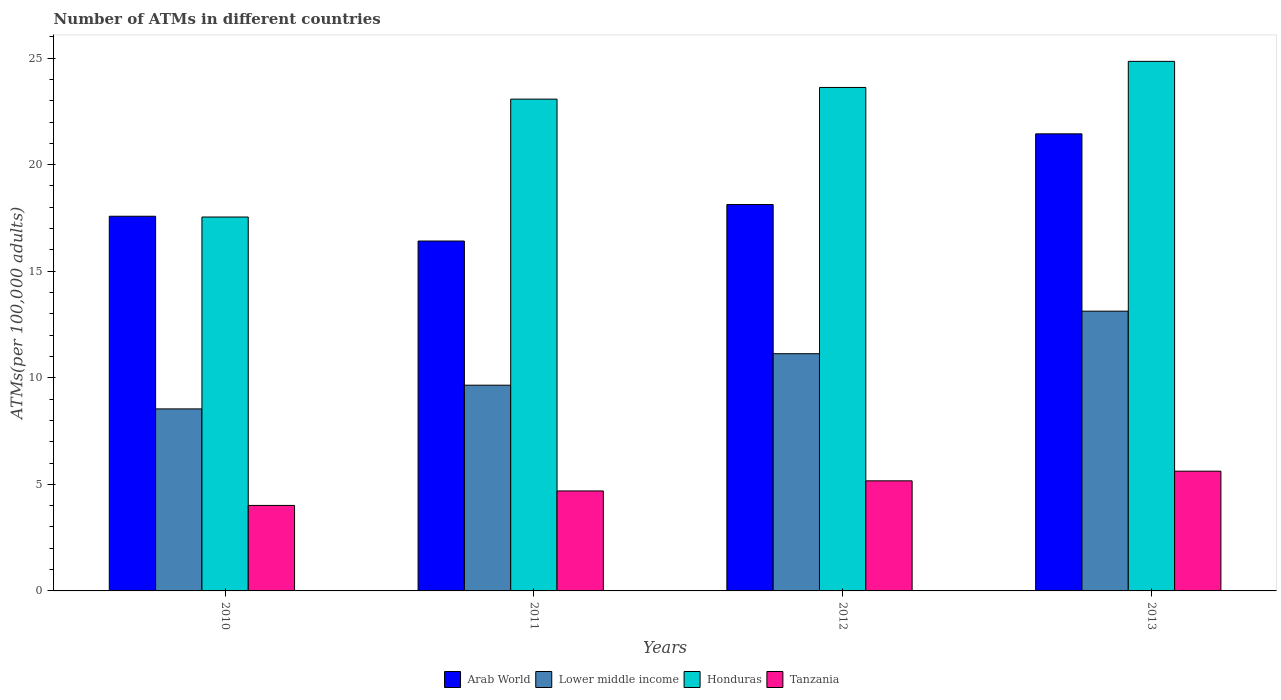How many different coloured bars are there?
Ensure brevity in your answer.  4. How many groups of bars are there?
Your answer should be very brief. 4. Are the number of bars per tick equal to the number of legend labels?
Your answer should be compact. Yes. How many bars are there on the 2nd tick from the left?
Give a very brief answer. 4. What is the label of the 2nd group of bars from the left?
Your answer should be compact. 2011. In how many cases, is the number of bars for a given year not equal to the number of legend labels?
Offer a terse response. 0. What is the number of ATMs in Tanzania in 2012?
Provide a short and direct response. 5.16. Across all years, what is the maximum number of ATMs in Tanzania?
Make the answer very short. 5.62. Across all years, what is the minimum number of ATMs in Arab World?
Your answer should be very brief. 16.42. In which year was the number of ATMs in Lower middle income minimum?
Your answer should be very brief. 2010. What is the total number of ATMs in Honduras in the graph?
Your answer should be compact. 89.08. What is the difference between the number of ATMs in Tanzania in 2010 and that in 2012?
Ensure brevity in your answer.  -1.15. What is the difference between the number of ATMs in Honduras in 2011 and the number of ATMs in Tanzania in 2013?
Ensure brevity in your answer.  17.45. What is the average number of ATMs in Lower middle income per year?
Offer a very short reply. 10.61. In the year 2013, what is the difference between the number of ATMs in Arab World and number of ATMs in Lower middle income?
Your answer should be very brief. 8.32. What is the ratio of the number of ATMs in Lower middle income in 2012 to that in 2013?
Your response must be concise. 0.85. Is the difference between the number of ATMs in Arab World in 2012 and 2013 greater than the difference between the number of ATMs in Lower middle income in 2012 and 2013?
Provide a short and direct response. No. What is the difference between the highest and the second highest number of ATMs in Arab World?
Provide a succinct answer. 3.32. What is the difference between the highest and the lowest number of ATMs in Tanzania?
Provide a short and direct response. 1.61. Is the sum of the number of ATMs in Tanzania in 2010 and 2011 greater than the maximum number of ATMs in Arab World across all years?
Offer a very short reply. No. What does the 2nd bar from the left in 2012 represents?
Ensure brevity in your answer.  Lower middle income. What does the 3rd bar from the right in 2010 represents?
Your answer should be compact. Lower middle income. Is it the case that in every year, the sum of the number of ATMs in Lower middle income and number of ATMs in Honduras is greater than the number of ATMs in Arab World?
Offer a very short reply. Yes. How many bars are there?
Provide a short and direct response. 16. Are all the bars in the graph horizontal?
Your response must be concise. No. How many years are there in the graph?
Your response must be concise. 4. Does the graph contain any zero values?
Give a very brief answer. No. How many legend labels are there?
Keep it short and to the point. 4. What is the title of the graph?
Your answer should be compact. Number of ATMs in different countries. What is the label or title of the Y-axis?
Provide a short and direct response. ATMs(per 100,0 adults). What is the ATMs(per 100,000 adults) in Arab World in 2010?
Offer a very short reply. 17.58. What is the ATMs(per 100,000 adults) of Lower middle income in 2010?
Ensure brevity in your answer.  8.54. What is the ATMs(per 100,000 adults) in Honduras in 2010?
Provide a short and direct response. 17.54. What is the ATMs(per 100,000 adults) of Tanzania in 2010?
Provide a succinct answer. 4.01. What is the ATMs(per 100,000 adults) in Arab World in 2011?
Offer a very short reply. 16.42. What is the ATMs(per 100,000 adults) in Lower middle income in 2011?
Your response must be concise. 9.65. What is the ATMs(per 100,000 adults) in Honduras in 2011?
Your answer should be compact. 23.07. What is the ATMs(per 100,000 adults) of Tanzania in 2011?
Provide a short and direct response. 4.69. What is the ATMs(per 100,000 adults) in Arab World in 2012?
Give a very brief answer. 18.13. What is the ATMs(per 100,000 adults) in Lower middle income in 2012?
Your answer should be compact. 11.13. What is the ATMs(per 100,000 adults) in Honduras in 2012?
Your response must be concise. 23.62. What is the ATMs(per 100,000 adults) of Tanzania in 2012?
Offer a very short reply. 5.16. What is the ATMs(per 100,000 adults) in Arab World in 2013?
Offer a terse response. 21.44. What is the ATMs(per 100,000 adults) in Lower middle income in 2013?
Keep it short and to the point. 13.13. What is the ATMs(per 100,000 adults) of Honduras in 2013?
Your answer should be very brief. 24.85. What is the ATMs(per 100,000 adults) of Tanzania in 2013?
Your response must be concise. 5.62. Across all years, what is the maximum ATMs(per 100,000 adults) in Arab World?
Your answer should be very brief. 21.44. Across all years, what is the maximum ATMs(per 100,000 adults) of Lower middle income?
Make the answer very short. 13.13. Across all years, what is the maximum ATMs(per 100,000 adults) in Honduras?
Ensure brevity in your answer.  24.85. Across all years, what is the maximum ATMs(per 100,000 adults) of Tanzania?
Offer a terse response. 5.62. Across all years, what is the minimum ATMs(per 100,000 adults) in Arab World?
Offer a very short reply. 16.42. Across all years, what is the minimum ATMs(per 100,000 adults) of Lower middle income?
Provide a short and direct response. 8.54. Across all years, what is the minimum ATMs(per 100,000 adults) of Honduras?
Your response must be concise. 17.54. Across all years, what is the minimum ATMs(per 100,000 adults) of Tanzania?
Your answer should be compact. 4.01. What is the total ATMs(per 100,000 adults) in Arab World in the graph?
Your response must be concise. 73.57. What is the total ATMs(per 100,000 adults) of Lower middle income in the graph?
Make the answer very short. 42.45. What is the total ATMs(per 100,000 adults) of Honduras in the graph?
Your response must be concise. 89.08. What is the total ATMs(per 100,000 adults) of Tanzania in the graph?
Give a very brief answer. 19.48. What is the difference between the ATMs(per 100,000 adults) in Arab World in 2010 and that in 2011?
Your answer should be compact. 1.16. What is the difference between the ATMs(per 100,000 adults) in Lower middle income in 2010 and that in 2011?
Make the answer very short. -1.11. What is the difference between the ATMs(per 100,000 adults) of Honduras in 2010 and that in 2011?
Your answer should be very brief. -5.53. What is the difference between the ATMs(per 100,000 adults) of Tanzania in 2010 and that in 2011?
Your answer should be compact. -0.68. What is the difference between the ATMs(per 100,000 adults) in Arab World in 2010 and that in 2012?
Your answer should be compact. -0.55. What is the difference between the ATMs(per 100,000 adults) of Lower middle income in 2010 and that in 2012?
Your answer should be very brief. -2.59. What is the difference between the ATMs(per 100,000 adults) in Honduras in 2010 and that in 2012?
Give a very brief answer. -6.08. What is the difference between the ATMs(per 100,000 adults) in Tanzania in 2010 and that in 2012?
Your answer should be compact. -1.15. What is the difference between the ATMs(per 100,000 adults) in Arab World in 2010 and that in 2013?
Give a very brief answer. -3.87. What is the difference between the ATMs(per 100,000 adults) of Lower middle income in 2010 and that in 2013?
Offer a terse response. -4.59. What is the difference between the ATMs(per 100,000 adults) in Honduras in 2010 and that in 2013?
Give a very brief answer. -7.3. What is the difference between the ATMs(per 100,000 adults) of Tanzania in 2010 and that in 2013?
Provide a short and direct response. -1.61. What is the difference between the ATMs(per 100,000 adults) in Arab World in 2011 and that in 2012?
Offer a very short reply. -1.71. What is the difference between the ATMs(per 100,000 adults) in Lower middle income in 2011 and that in 2012?
Your response must be concise. -1.48. What is the difference between the ATMs(per 100,000 adults) of Honduras in 2011 and that in 2012?
Offer a terse response. -0.55. What is the difference between the ATMs(per 100,000 adults) in Tanzania in 2011 and that in 2012?
Make the answer very short. -0.47. What is the difference between the ATMs(per 100,000 adults) of Arab World in 2011 and that in 2013?
Your answer should be very brief. -5.03. What is the difference between the ATMs(per 100,000 adults) of Lower middle income in 2011 and that in 2013?
Provide a short and direct response. -3.47. What is the difference between the ATMs(per 100,000 adults) of Honduras in 2011 and that in 2013?
Provide a short and direct response. -1.77. What is the difference between the ATMs(per 100,000 adults) of Tanzania in 2011 and that in 2013?
Your answer should be very brief. -0.93. What is the difference between the ATMs(per 100,000 adults) in Arab World in 2012 and that in 2013?
Ensure brevity in your answer.  -3.32. What is the difference between the ATMs(per 100,000 adults) in Lower middle income in 2012 and that in 2013?
Provide a short and direct response. -2. What is the difference between the ATMs(per 100,000 adults) in Honduras in 2012 and that in 2013?
Give a very brief answer. -1.22. What is the difference between the ATMs(per 100,000 adults) of Tanzania in 2012 and that in 2013?
Your response must be concise. -0.45. What is the difference between the ATMs(per 100,000 adults) of Arab World in 2010 and the ATMs(per 100,000 adults) of Lower middle income in 2011?
Make the answer very short. 7.93. What is the difference between the ATMs(per 100,000 adults) in Arab World in 2010 and the ATMs(per 100,000 adults) in Honduras in 2011?
Provide a succinct answer. -5.49. What is the difference between the ATMs(per 100,000 adults) of Arab World in 2010 and the ATMs(per 100,000 adults) of Tanzania in 2011?
Ensure brevity in your answer.  12.89. What is the difference between the ATMs(per 100,000 adults) in Lower middle income in 2010 and the ATMs(per 100,000 adults) in Honduras in 2011?
Ensure brevity in your answer.  -14.53. What is the difference between the ATMs(per 100,000 adults) of Lower middle income in 2010 and the ATMs(per 100,000 adults) of Tanzania in 2011?
Provide a succinct answer. 3.85. What is the difference between the ATMs(per 100,000 adults) in Honduras in 2010 and the ATMs(per 100,000 adults) in Tanzania in 2011?
Provide a succinct answer. 12.85. What is the difference between the ATMs(per 100,000 adults) in Arab World in 2010 and the ATMs(per 100,000 adults) in Lower middle income in 2012?
Your response must be concise. 6.45. What is the difference between the ATMs(per 100,000 adults) of Arab World in 2010 and the ATMs(per 100,000 adults) of Honduras in 2012?
Provide a succinct answer. -6.04. What is the difference between the ATMs(per 100,000 adults) in Arab World in 2010 and the ATMs(per 100,000 adults) in Tanzania in 2012?
Offer a terse response. 12.41. What is the difference between the ATMs(per 100,000 adults) in Lower middle income in 2010 and the ATMs(per 100,000 adults) in Honduras in 2012?
Your answer should be compact. -15.08. What is the difference between the ATMs(per 100,000 adults) of Lower middle income in 2010 and the ATMs(per 100,000 adults) of Tanzania in 2012?
Your answer should be very brief. 3.37. What is the difference between the ATMs(per 100,000 adults) in Honduras in 2010 and the ATMs(per 100,000 adults) in Tanzania in 2012?
Your answer should be very brief. 12.38. What is the difference between the ATMs(per 100,000 adults) of Arab World in 2010 and the ATMs(per 100,000 adults) of Lower middle income in 2013?
Your response must be concise. 4.45. What is the difference between the ATMs(per 100,000 adults) of Arab World in 2010 and the ATMs(per 100,000 adults) of Honduras in 2013?
Offer a terse response. -7.27. What is the difference between the ATMs(per 100,000 adults) of Arab World in 2010 and the ATMs(per 100,000 adults) of Tanzania in 2013?
Your answer should be compact. 11.96. What is the difference between the ATMs(per 100,000 adults) of Lower middle income in 2010 and the ATMs(per 100,000 adults) of Honduras in 2013?
Offer a very short reply. -16.31. What is the difference between the ATMs(per 100,000 adults) in Lower middle income in 2010 and the ATMs(per 100,000 adults) in Tanzania in 2013?
Your answer should be very brief. 2.92. What is the difference between the ATMs(per 100,000 adults) of Honduras in 2010 and the ATMs(per 100,000 adults) of Tanzania in 2013?
Provide a short and direct response. 11.92. What is the difference between the ATMs(per 100,000 adults) of Arab World in 2011 and the ATMs(per 100,000 adults) of Lower middle income in 2012?
Offer a terse response. 5.29. What is the difference between the ATMs(per 100,000 adults) in Arab World in 2011 and the ATMs(per 100,000 adults) in Honduras in 2012?
Your response must be concise. -7.21. What is the difference between the ATMs(per 100,000 adults) of Arab World in 2011 and the ATMs(per 100,000 adults) of Tanzania in 2012?
Give a very brief answer. 11.25. What is the difference between the ATMs(per 100,000 adults) in Lower middle income in 2011 and the ATMs(per 100,000 adults) in Honduras in 2012?
Your answer should be very brief. -13.97. What is the difference between the ATMs(per 100,000 adults) in Lower middle income in 2011 and the ATMs(per 100,000 adults) in Tanzania in 2012?
Give a very brief answer. 4.49. What is the difference between the ATMs(per 100,000 adults) of Honduras in 2011 and the ATMs(per 100,000 adults) of Tanzania in 2012?
Your answer should be compact. 17.91. What is the difference between the ATMs(per 100,000 adults) in Arab World in 2011 and the ATMs(per 100,000 adults) in Lower middle income in 2013?
Ensure brevity in your answer.  3.29. What is the difference between the ATMs(per 100,000 adults) of Arab World in 2011 and the ATMs(per 100,000 adults) of Honduras in 2013?
Offer a very short reply. -8.43. What is the difference between the ATMs(per 100,000 adults) in Arab World in 2011 and the ATMs(per 100,000 adults) in Tanzania in 2013?
Your answer should be very brief. 10.8. What is the difference between the ATMs(per 100,000 adults) in Lower middle income in 2011 and the ATMs(per 100,000 adults) in Honduras in 2013?
Give a very brief answer. -15.19. What is the difference between the ATMs(per 100,000 adults) of Lower middle income in 2011 and the ATMs(per 100,000 adults) of Tanzania in 2013?
Keep it short and to the point. 4.03. What is the difference between the ATMs(per 100,000 adults) in Honduras in 2011 and the ATMs(per 100,000 adults) in Tanzania in 2013?
Your answer should be very brief. 17.45. What is the difference between the ATMs(per 100,000 adults) in Arab World in 2012 and the ATMs(per 100,000 adults) in Lower middle income in 2013?
Provide a short and direct response. 5. What is the difference between the ATMs(per 100,000 adults) in Arab World in 2012 and the ATMs(per 100,000 adults) in Honduras in 2013?
Provide a short and direct response. -6.72. What is the difference between the ATMs(per 100,000 adults) of Arab World in 2012 and the ATMs(per 100,000 adults) of Tanzania in 2013?
Provide a short and direct response. 12.51. What is the difference between the ATMs(per 100,000 adults) of Lower middle income in 2012 and the ATMs(per 100,000 adults) of Honduras in 2013?
Provide a short and direct response. -13.72. What is the difference between the ATMs(per 100,000 adults) in Lower middle income in 2012 and the ATMs(per 100,000 adults) in Tanzania in 2013?
Provide a short and direct response. 5.51. What is the difference between the ATMs(per 100,000 adults) in Honduras in 2012 and the ATMs(per 100,000 adults) in Tanzania in 2013?
Offer a terse response. 18. What is the average ATMs(per 100,000 adults) of Arab World per year?
Your answer should be very brief. 18.39. What is the average ATMs(per 100,000 adults) in Lower middle income per year?
Your response must be concise. 10.61. What is the average ATMs(per 100,000 adults) in Honduras per year?
Offer a very short reply. 22.27. What is the average ATMs(per 100,000 adults) in Tanzania per year?
Ensure brevity in your answer.  4.87. In the year 2010, what is the difference between the ATMs(per 100,000 adults) in Arab World and ATMs(per 100,000 adults) in Lower middle income?
Your response must be concise. 9.04. In the year 2010, what is the difference between the ATMs(per 100,000 adults) of Arab World and ATMs(per 100,000 adults) of Honduras?
Offer a very short reply. 0.04. In the year 2010, what is the difference between the ATMs(per 100,000 adults) in Arab World and ATMs(per 100,000 adults) in Tanzania?
Keep it short and to the point. 13.57. In the year 2010, what is the difference between the ATMs(per 100,000 adults) of Lower middle income and ATMs(per 100,000 adults) of Honduras?
Offer a very short reply. -9. In the year 2010, what is the difference between the ATMs(per 100,000 adults) in Lower middle income and ATMs(per 100,000 adults) in Tanzania?
Make the answer very short. 4.53. In the year 2010, what is the difference between the ATMs(per 100,000 adults) of Honduras and ATMs(per 100,000 adults) of Tanzania?
Offer a very short reply. 13.53. In the year 2011, what is the difference between the ATMs(per 100,000 adults) in Arab World and ATMs(per 100,000 adults) in Lower middle income?
Offer a terse response. 6.76. In the year 2011, what is the difference between the ATMs(per 100,000 adults) of Arab World and ATMs(per 100,000 adults) of Honduras?
Your answer should be very brief. -6.66. In the year 2011, what is the difference between the ATMs(per 100,000 adults) in Arab World and ATMs(per 100,000 adults) in Tanzania?
Provide a succinct answer. 11.73. In the year 2011, what is the difference between the ATMs(per 100,000 adults) of Lower middle income and ATMs(per 100,000 adults) of Honduras?
Offer a terse response. -13.42. In the year 2011, what is the difference between the ATMs(per 100,000 adults) of Lower middle income and ATMs(per 100,000 adults) of Tanzania?
Offer a terse response. 4.96. In the year 2011, what is the difference between the ATMs(per 100,000 adults) in Honduras and ATMs(per 100,000 adults) in Tanzania?
Your answer should be compact. 18.38. In the year 2012, what is the difference between the ATMs(per 100,000 adults) in Arab World and ATMs(per 100,000 adults) in Lower middle income?
Your answer should be very brief. 7. In the year 2012, what is the difference between the ATMs(per 100,000 adults) of Arab World and ATMs(per 100,000 adults) of Honduras?
Provide a short and direct response. -5.49. In the year 2012, what is the difference between the ATMs(per 100,000 adults) in Arab World and ATMs(per 100,000 adults) in Tanzania?
Make the answer very short. 12.96. In the year 2012, what is the difference between the ATMs(per 100,000 adults) in Lower middle income and ATMs(per 100,000 adults) in Honduras?
Your response must be concise. -12.49. In the year 2012, what is the difference between the ATMs(per 100,000 adults) of Lower middle income and ATMs(per 100,000 adults) of Tanzania?
Give a very brief answer. 5.96. In the year 2012, what is the difference between the ATMs(per 100,000 adults) in Honduras and ATMs(per 100,000 adults) in Tanzania?
Ensure brevity in your answer.  18.46. In the year 2013, what is the difference between the ATMs(per 100,000 adults) of Arab World and ATMs(per 100,000 adults) of Lower middle income?
Offer a terse response. 8.32. In the year 2013, what is the difference between the ATMs(per 100,000 adults) of Arab World and ATMs(per 100,000 adults) of Honduras?
Your answer should be very brief. -3.4. In the year 2013, what is the difference between the ATMs(per 100,000 adults) of Arab World and ATMs(per 100,000 adults) of Tanzania?
Keep it short and to the point. 15.83. In the year 2013, what is the difference between the ATMs(per 100,000 adults) of Lower middle income and ATMs(per 100,000 adults) of Honduras?
Your answer should be compact. -11.72. In the year 2013, what is the difference between the ATMs(per 100,000 adults) of Lower middle income and ATMs(per 100,000 adults) of Tanzania?
Give a very brief answer. 7.51. In the year 2013, what is the difference between the ATMs(per 100,000 adults) in Honduras and ATMs(per 100,000 adults) in Tanzania?
Provide a succinct answer. 19.23. What is the ratio of the ATMs(per 100,000 adults) of Arab World in 2010 to that in 2011?
Your answer should be very brief. 1.07. What is the ratio of the ATMs(per 100,000 adults) in Lower middle income in 2010 to that in 2011?
Ensure brevity in your answer.  0.88. What is the ratio of the ATMs(per 100,000 adults) of Honduras in 2010 to that in 2011?
Keep it short and to the point. 0.76. What is the ratio of the ATMs(per 100,000 adults) of Tanzania in 2010 to that in 2011?
Your answer should be compact. 0.86. What is the ratio of the ATMs(per 100,000 adults) in Arab World in 2010 to that in 2012?
Provide a succinct answer. 0.97. What is the ratio of the ATMs(per 100,000 adults) in Lower middle income in 2010 to that in 2012?
Your response must be concise. 0.77. What is the ratio of the ATMs(per 100,000 adults) of Honduras in 2010 to that in 2012?
Your answer should be very brief. 0.74. What is the ratio of the ATMs(per 100,000 adults) in Tanzania in 2010 to that in 2012?
Keep it short and to the point. 0.78. What is the ratio of the ATMs(per 100,000 adults) of Arab World in 2010 to that in 2013?
Give a very brief answer. 0.82. What is the ratio of the ATMs(per 100,000 adults) in Lower middle income in 2010 to that in 2013?
Provide a succinct answer. 0.65. What is the ratio of the ATMs(per 100,000 adults) in Honduras in 2010 to that in 2013?
Provide a short and direct response. 0.71. What is the ratio of the ATMs(per 100,000 adults) in Tanzania in 2010 to that in 2013?
Your answer should be very brief. 0.71. What is the ratio of the ATMs(per 100,000 adults) of Arab World in 2011 to that in 2012?
Provide a short and direct response. 0.91. What is the ratio of the ATMs(per 100,000 adults) of Lower middle income in 2011 to that in 2012?
Make the answer very short. 0.87. What is the ratio of the ATMs(per 100,000 adults) of Honduras in 2011 to that in 2012?
Provide a succinct answer. 0.98. What is the ratio of the ATMs(per 100,000 adults) in Tanzania in 2011 to that in 2012?
Your response must be concise. 0.91. What is the ratio of the ATMs(per 100,000 adults) in Arab World in 2011 to that in 2013?
Your answer should be compact. 0.77. What is the ratio of the ATMs(per 100,000 adults) in Lower middle income in 2011 to that in 2013?
Provide a succinct answer. 0.74. What is the ratio of the ATMs(per 100,000 adults) in Honduras in 2011 to that in 2013?
Your response must be concise. 0.93. What is the ratio of the ATMs(per 100,000 adults) of Tanzania in 2011 to that in 2013?
Offer a very short reply. 0.83. What is the ratio of the ATMs(per 100,000 adults) of Arab World in 2012 to that in 2013?
Provide a short and direct response. 0.85. What is the ratio of the ATMs(per 100,000 adults) in Lower middle income in 2012 to that in 2013?
Make the answer very short. 0.85. What is the ratio of the ATMs(per 100,000 adults) of Honduras in 2012 to that in 2013?
Offer a terse response. 0.95. What is the ratio of the ATMs(per 100,000 adults) of Tanzania in 2012 to that in 2013?
Your answer should be very brief. 0.92. What is the difference between the highest and the second highest ATMs(per 100,000 adults) of Arab World?
Your answer should be compact. 3.32. What is the difference between the highest and the second highest ATMs(per 100,000 adults) of Lower middle income?
Your answer should be very brief. 2. What is the difference between the highest and the second highest ATMs(per 100,000 adults) in Honduras?
Your answer should be compact. 1.22. What is the difference between the highest and the second highest ATMs(per 100,000 adults) of Tanzania?
Offer a very short reply. 0.45. What is the difference between the highest and the lowest ATMs(per 100,000 adults) in Arab World?
Your response must be concise. 5.03. What is the difference between the highest and the lowest ATMs(per 100,000 adults) of Lower middle income?
Give a very brief answer. 4.59. What is the difference between the highest and the lowest ATMs(per 100,000 adults) of Honduras?
Ensure brevity in your answer.  7.3. What is the difference between the highest and the lowest ATMs(per 100,000 adults) of Tanzania?
Keep it short and to the point. 1.61. 